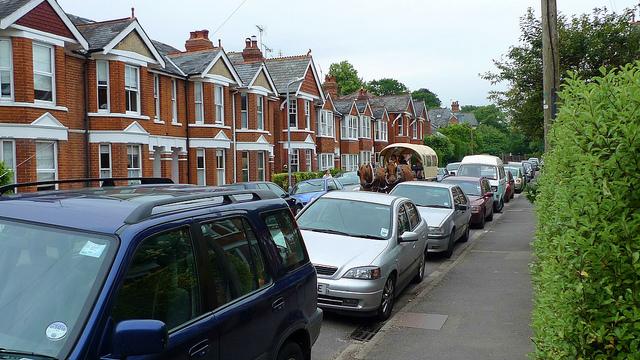Are there many residents in this neighborhood?
Write a very short answer. Yes. What color are the houses?
Be succinct. Red. How many cars are on the near side of the street?
Concise answer only. 10. 